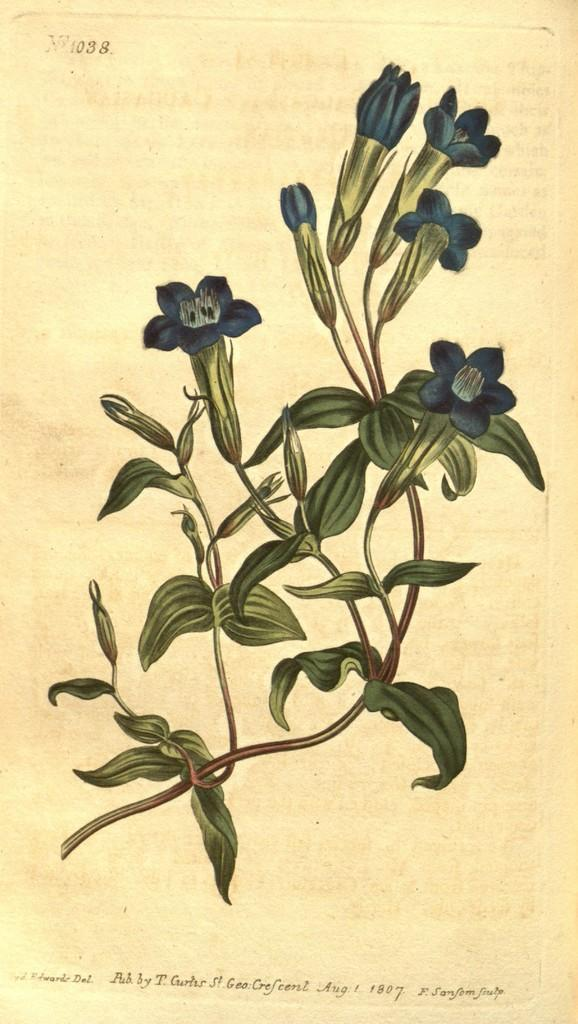What type of natural elements can be seen in the image? There are leaves in the image. Is there any text present in the image? Yes, there is text written at the bottom of the image. What type of bucket is depicted in the image? There is no bucket present in the image. What part of the leaves is visible in the image? The entire leaves are visible in the image, as there is no specific part mentioned. 